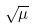<formula> <loc_0><loc_0><loc_500><loc_500>\sqrt { \mu }</formula> 